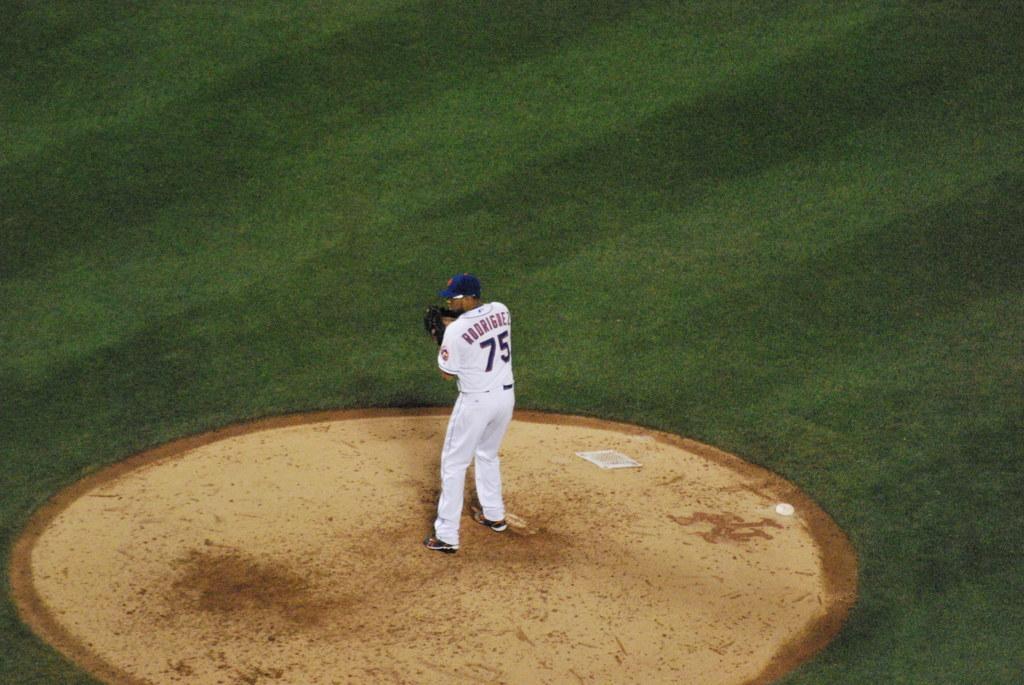How would you summarize this image in a sentence or two? This picture shows a man standing, He wore gloves to his hands and a cap on his head and we see grass on the ground and he wore a white color dress. 